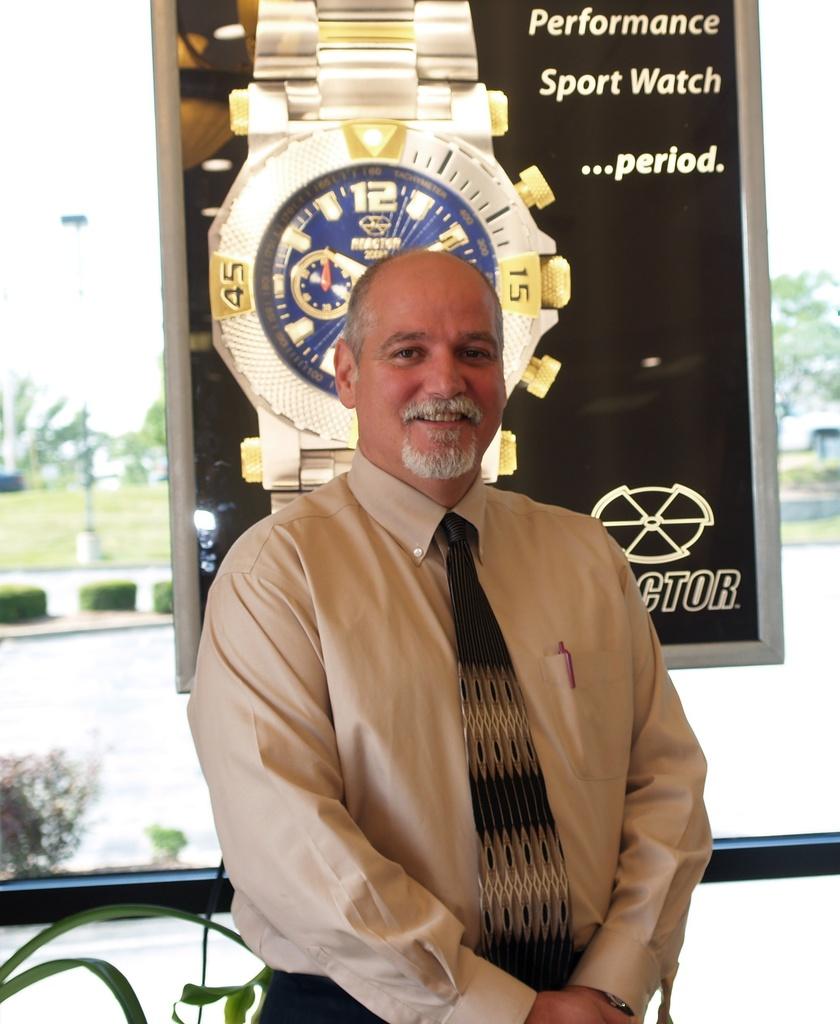What kind of watch is this?
Provide a short and direct response. Sport watch. What is the number on the right side of the man?
Your answer should be compact. 15. 